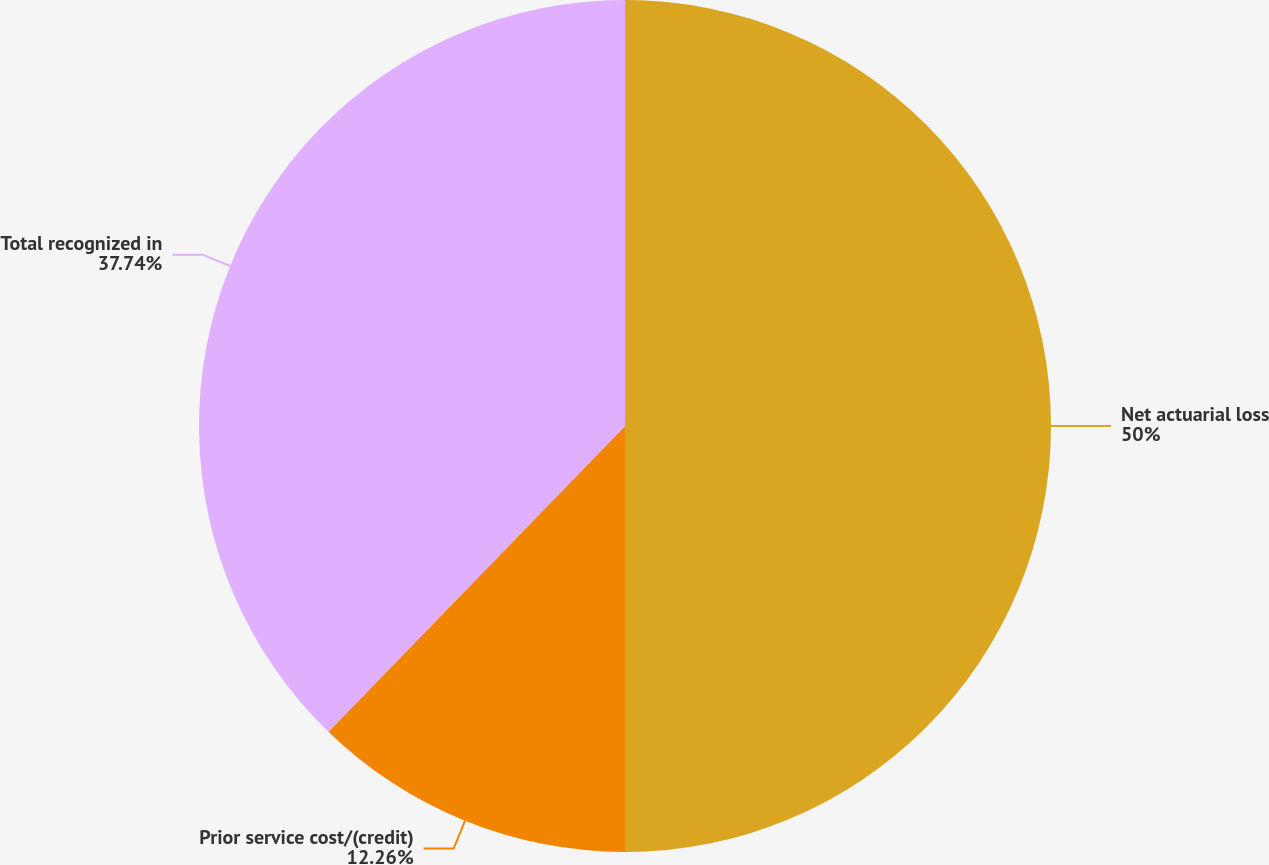<chart> <loc_0><loc_0><loc_500><loc_500><pie_chart><fcel>Net actuarial loss<fcel>Prior service cost/(credit)<fcel>Total recognized in<nl><fcel>50.0%<fcel>12.26%<fcel>37.74%<nl></chart> 